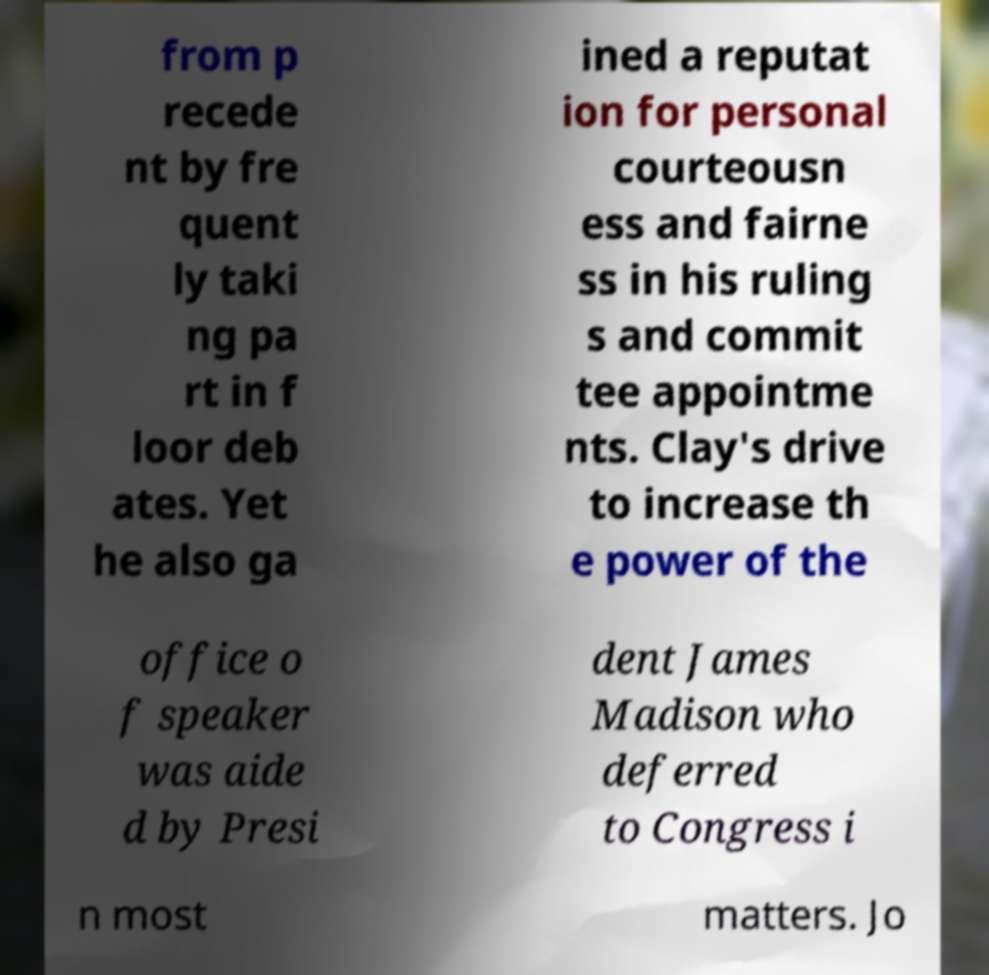There's text embedded in this image that I need extracted. Can you transcribe it verbatim? from p recede nt by fre quent ly taki ng pa rt in f loor deb ates. Yet he also ga ined a reputat ion for personal courteousn ess and fairne ss in his ruling s and commit tee appointme nts. Clay's drive to increase th e power of the office o f speaker was aide d by Presi dent James Madison who deferred to Congress i n most matters. Jo 